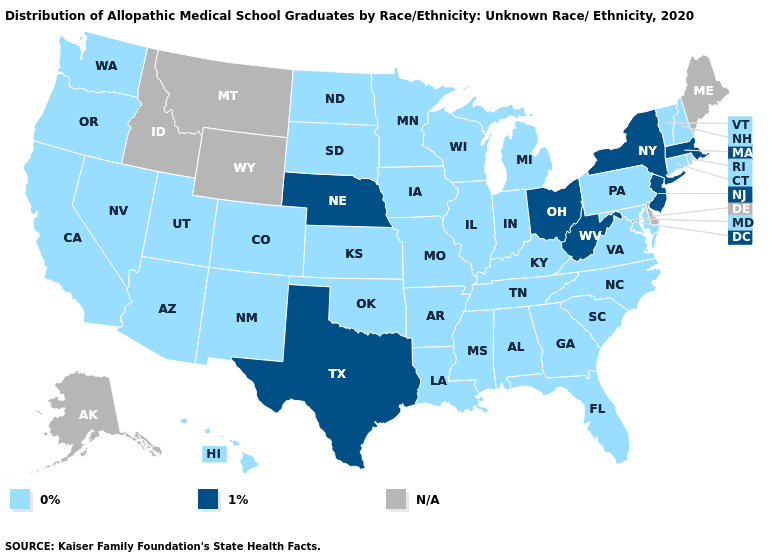Does Tennessee have the highest value in the South?
Answer briefly. No. Is the legend a continuous bar?
Give a very brief answer. No. Name the states that have a value in the range 0%?
Answer briefly. Alabama, Arizona, Arkansas, California, Colorado, Connecticut, Florida, Georgia, Hawaii, Illinois, Indiana, Iowa, Kansas, Kentucky, Louisiana, Maryland, Michigan, Minnesota, Mississippi, Missouri, Nevada, New Hampshire, New Mexico, North Carolina, North Dakota, Oklahoma, Oregon, Pennsylvania, Rhode Island, South Carolina, South Dakota, Tennessee, Utah, Vermont, Virginia, Washington, Wisconsin. How many symbols are there in the legend?
Answer briefly. 3. Does the first symbol in the legend represent the smallest category?
Write a very short answer. Yes. Name the states that have a value in the range 0%?
Give a very brief answer. Alabama, Arizona, Arkansas, California, Colorado, Connecticut, Florida, Georgia, Hawaii, Illinois, Indiana, Iowa, Kansas, Kentucky, Louisiana, Maryland, Michigan, Minnesota, Mississippi, Missouri, Nevada, New Hampshire, New Mexico, North Carolina, North Dakota, Oklahoma, Oregon, Pennsylvania, Rhode Island, South Carolina, South Dakota, Tennessee, Utah, Vermont, Virginia, Washington, Wisconsin. Does the first symbol in the legend represent the smallest category?
Short answer required. Yes. Name the states that have a value in the range N/A?
Keep it brief. Alaska, Delaware, Idaho, Maine, Montana, Wyoming. Among the states that border Colorado , which have the lowest value?
Write a very short answer. Arizona, Kansas, New Mexico, Oklahoma, Utah. Name the states that have a value in the range 1%?
Quick response, please. Massachusetts, Nebraska, New Jersey, New York, Ohio, Texas, West Virginia. Among the states that border Virginia , does West Virginia have the lowest value?
Answer briefly. No. What is the value of South Carolina?
Be succinct. 0%. What is the value of Vermont?
Quick response, please. 0%. 